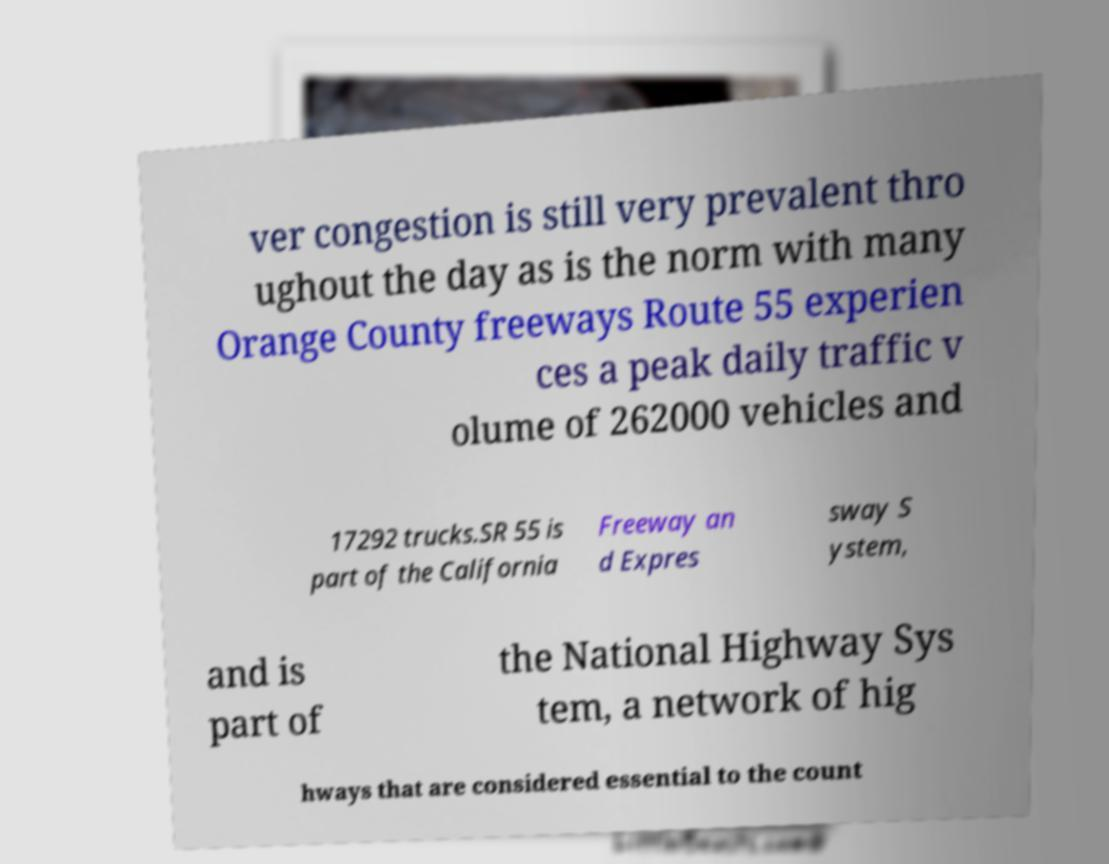Can you read and provide the text displayed in the image?This photo seems to have some interesting text. Can you extract and type it out for me? ver congestion is still very prevalent thro ughout the day as is the norm with many Orange County freeways Route 55 experien ces a peak daily traffic v olume of 262000 vehicles and 17292 trucks.SR 55 is part of the California Freeway an d Expres sway S ystem, and is part of the National Highway Sys tem, a network of hig hways that are considered essential to the count 